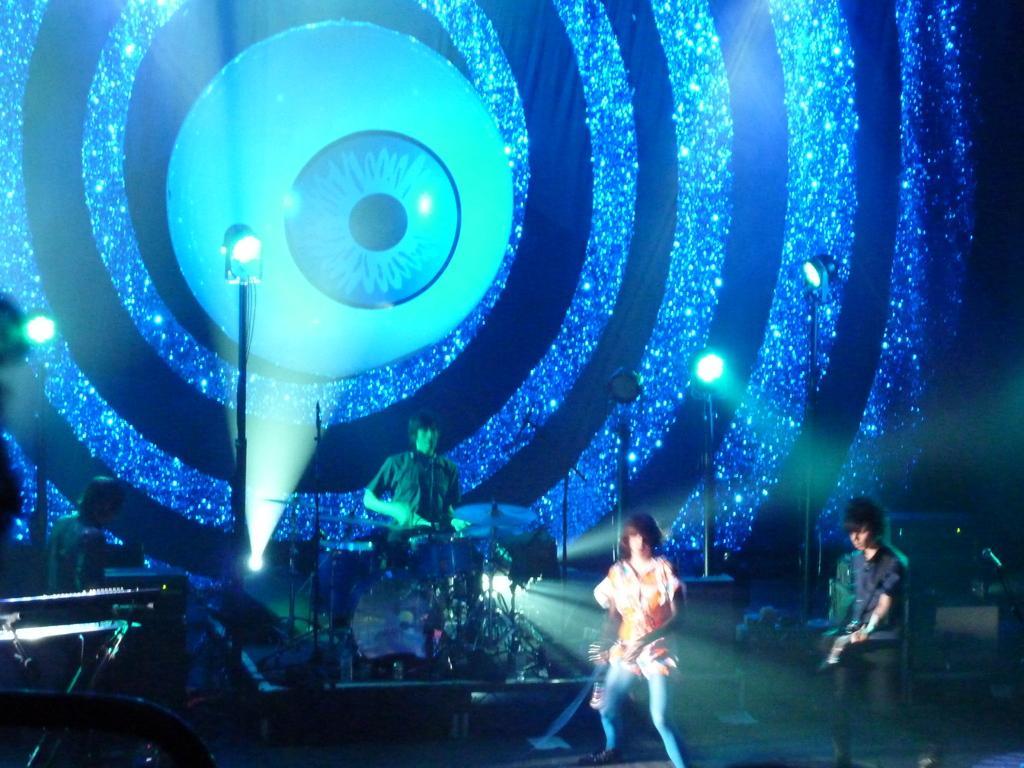Describe this image in one or two sentences. In this image we can see, there are some people performing on the stage, and in the back we can see some poles. 